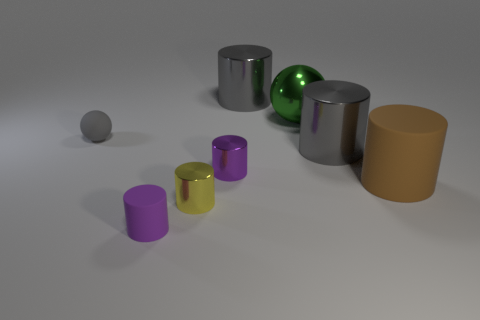Do the yellow thing and the large green metallic object have the same shape?
Your answer should be compact. No. There is a large brown thing; how many objects are to the right of it?
Keep it short and to the point. 0. There is a big cylinder that is to the right of the big metal object in front of the shiny ball; what color is it?
Provide a succinct answer. Brown. How many other objects are there of the same material as the brown object?
Provide a succinct answer. 2. Is the number of tiny gray rubber spheres that are right of the tiny rubber cylinder the same as the number of brown cylinders?
Your answer should be compact. No. What material is the tiny purple cylinder that is on the right side of the small purple thing in front of the matte cylinder that is on the right side of the small yellow metallic cylinder?
Your answer should be very brief. Metal. The metal cylinder that is behind the big ball is what color?
Offer a very short reply. Gray. Are there any other things that are the same shape as the gray rubber object?
Your response must be concise. Yes. What size is the ball to the right of the rubber cylinder in front of the brown object?
Keep it short and to the point. Large. Are there the same number of gray things that are to the right of the rubber sphere and big brown matte objects on the left side of the brown rubber object?
Give a very brief answer. No. 